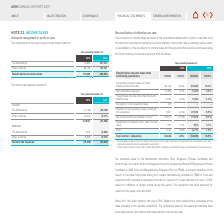According to Asm International Nv's financial document, What does the table show? The income tax expense. The document states: "The income tax expense consists of:..." Also, What is the total current income tax expense for 2019? According to the financial document, (37,420). The relevant text states: "(10,502) (37,420)..." Also, What is the current income tax expense for The Netherlands in 2018 and 2019 respectively? The document shows two values: (4,128) and (28,409). From the document: "The Netherlands (4,128) (28,409) The Netherlands (4,128) (28,409)..." Also, can you calculate: What is the percentage change in total Income tax expense from 2018 to 2019? To answer this question, I need to perform calculations using the financial data. The calculation is: (-53,650-(-15,436))/-15,436, which equals 247.56 (percentage). This is based on the information: "Income tax expense (15,436) (53,650) Income tax expense (15,436) (53,650)..." The key data points involved are: 15,436, 53,650. Also, can you calculate: What is the Current income tax expense for The Netherlands expressed as a percentage of Total income tax expense? To answer this question, I need to perform calculations using the financial data. The calculation is: -28,409/-53,650, which equals 52.95 (percentage). This is based on the information: "Income tax expense (15,436) (53,650) The Netherlands (4,128) (28,409)..." The key data points involved are: 28,409, 53,650. Also, can you calculate: What is the change in total Current income tax expense from 2018 to 2019? Based on the calculation: -37,420-(-10,502), the result is -26918. This is based on the information: "(10,502) (37,420) (10,502) (37,420)..." The key data points involved are: 10,502, 37,420. 